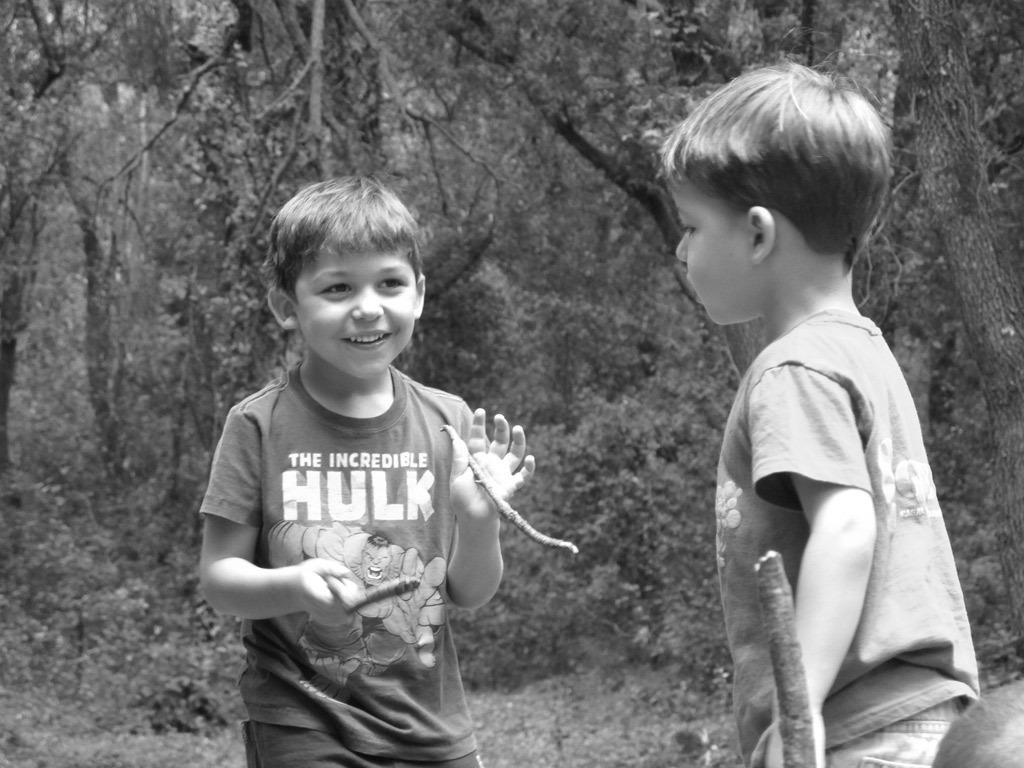Please provide a concise description of this image. There is a kid standing and holding two small sticks in his hands and there is another kid standing in front of him and there are trees in the background. 